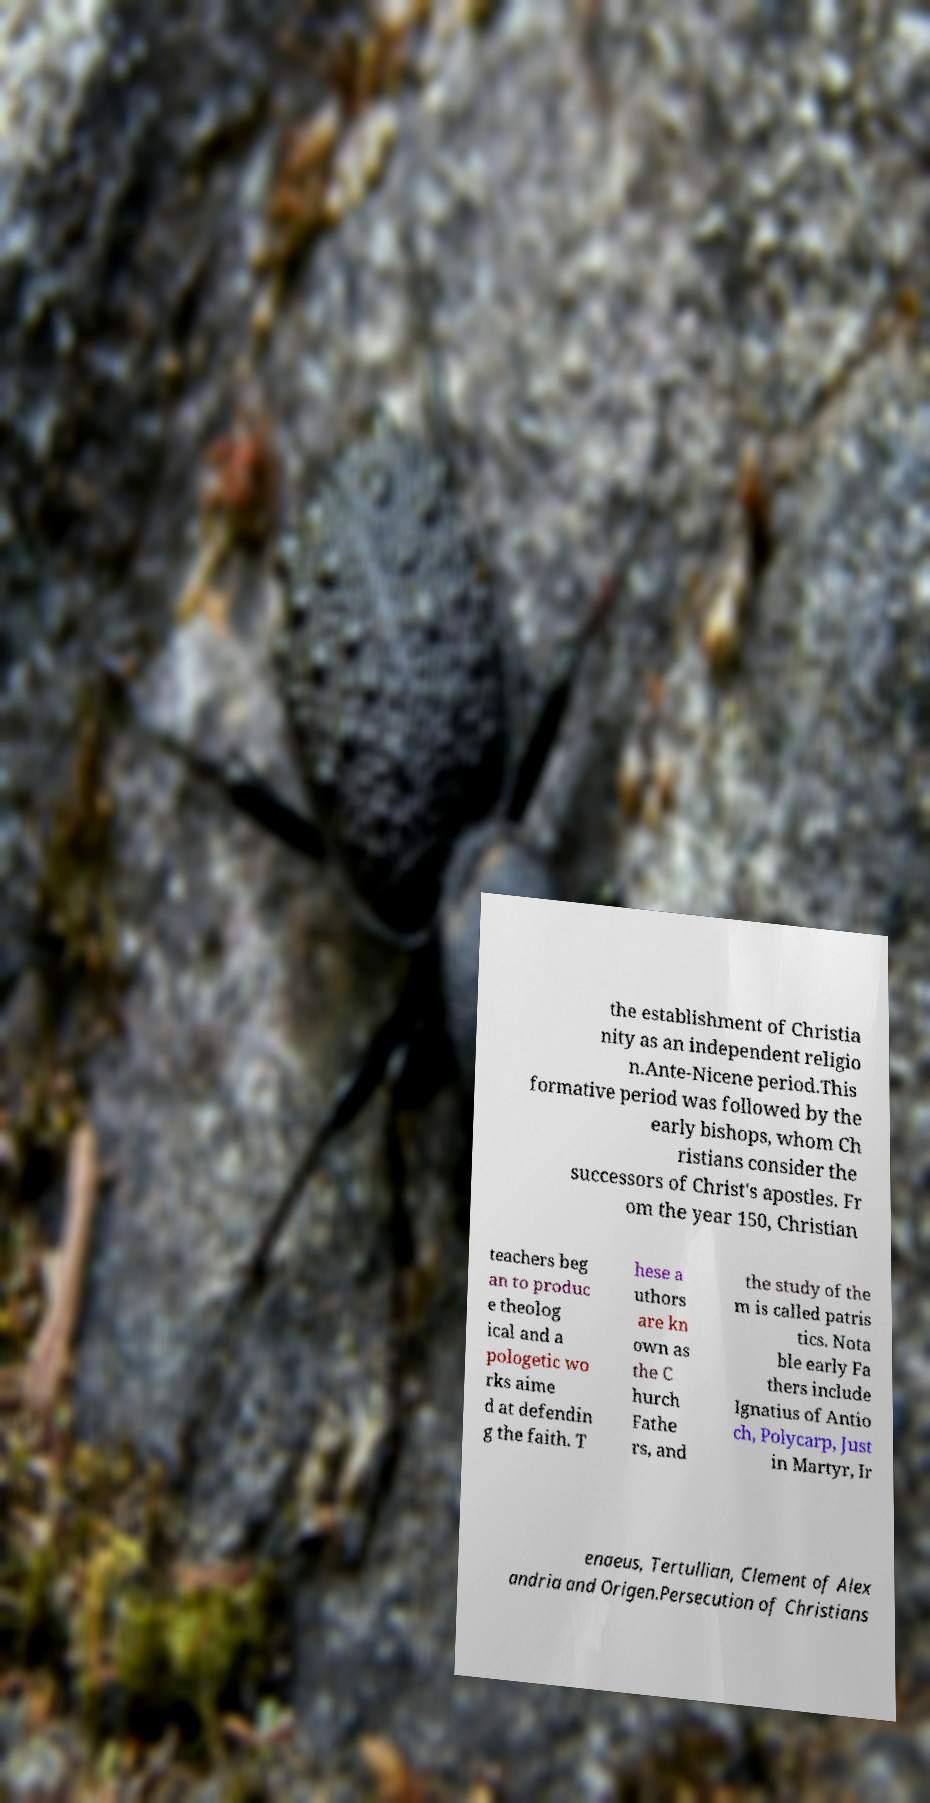Can you accurately transcribe the text from the provided image for me? the establishment of Christia nity as an independent religio n.Ante-Nicene period.This formative period was followed by the early bishops, whom Ch ristians consider the successors of Christ's apostles. Fr om the year 150, Christian teachers beg an to produc e theolog ical and a pologetic wo rks aime d at defendin g the faith. T hese a uthors are kn own as the C hurch Fathe rs, and the study of the m is called patris tics. Nota ble early Fa thers include Ignatius of Antio ch, Polycarp, Just in Martyr, Ir enaeus, Tertullian, Clement of Alex andria and Origen.Persecution of Christians 